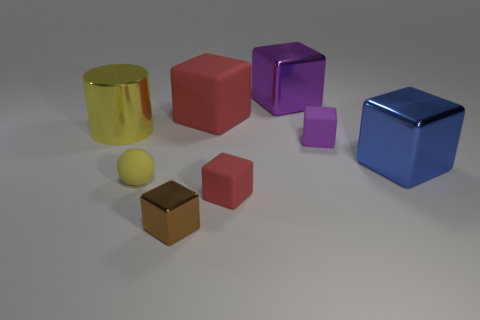Add 1 cyan metallic cubes. How many objects exist? 9 Subtract 2 cubes. How many cubes are left? 4 Subtract all cyan blocks. Subtract all gray cylinders. How many blocks are left? 6 Subtract all red cylinders. How many red balls are left? 0 Subtract all big purple objects. Subtract all big yellow cylinders. How many objects are left? 6 Add 6 large blue objects. How many large blue objects are left? 7 Add 6 large blue shiny objects. How many large blue shiny objects exist? 7 Subtract all red blocks. How many blocks are left? 4 Subtract all purple matte cubes. How many cubes are left? 5 Subtract 1 yellow cylinders. How many objects are left? 7 